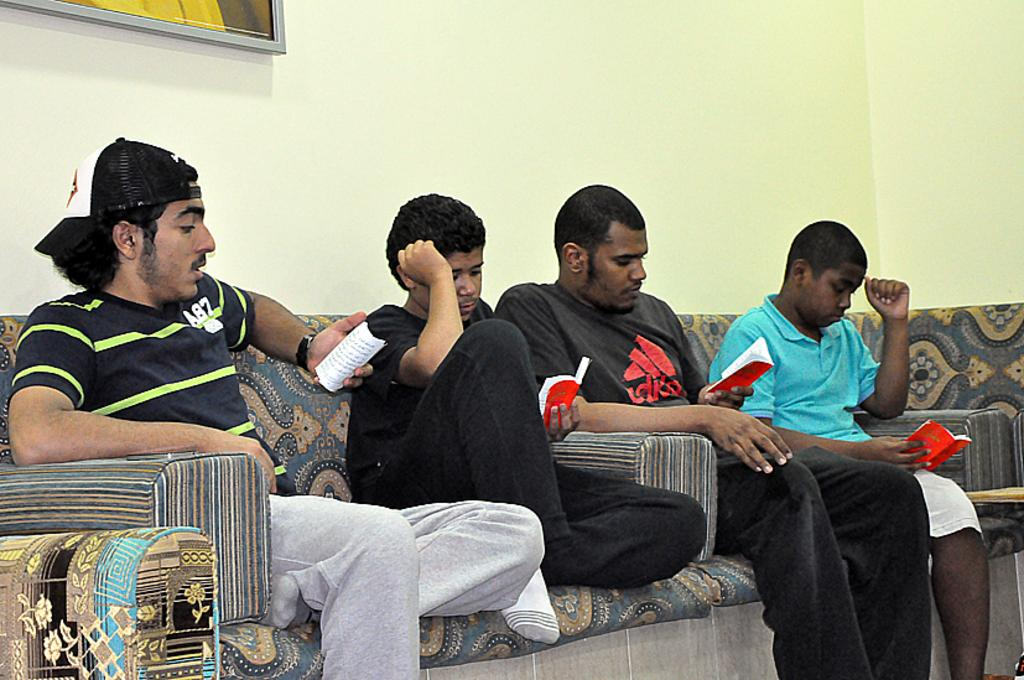What are the men in the image doing? The men in the image are sitting on a sofa. What are the men holding while sitting on the sofa? The men are holding books. What can be seen on the wall in the background of the image? There is a frame on the wall in the background of the image. What type of cake is being served to the men in the image? There is no cake present in the image; the men are holding books. 